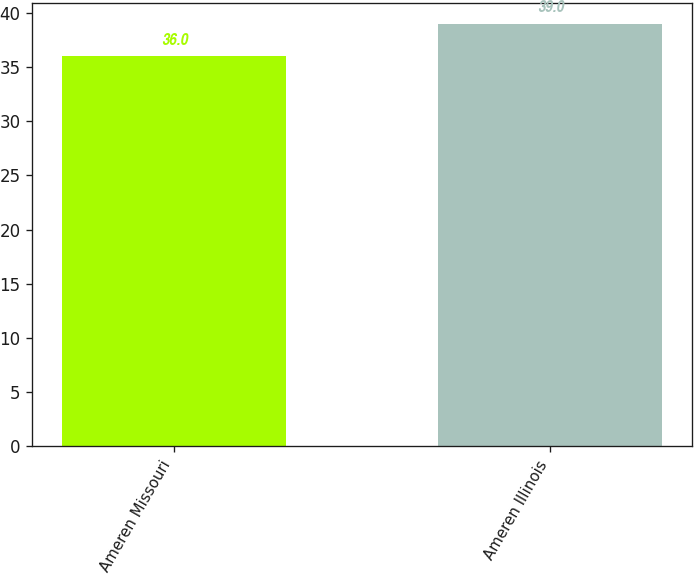Convert chart. <chart><loc_0><loc_0><loc_500><loc_500><bar_chart><fcel>Ameren Missouri<fcel>Ameren Illinois<nl><fcel>36<fcel>39<nl></chart> 